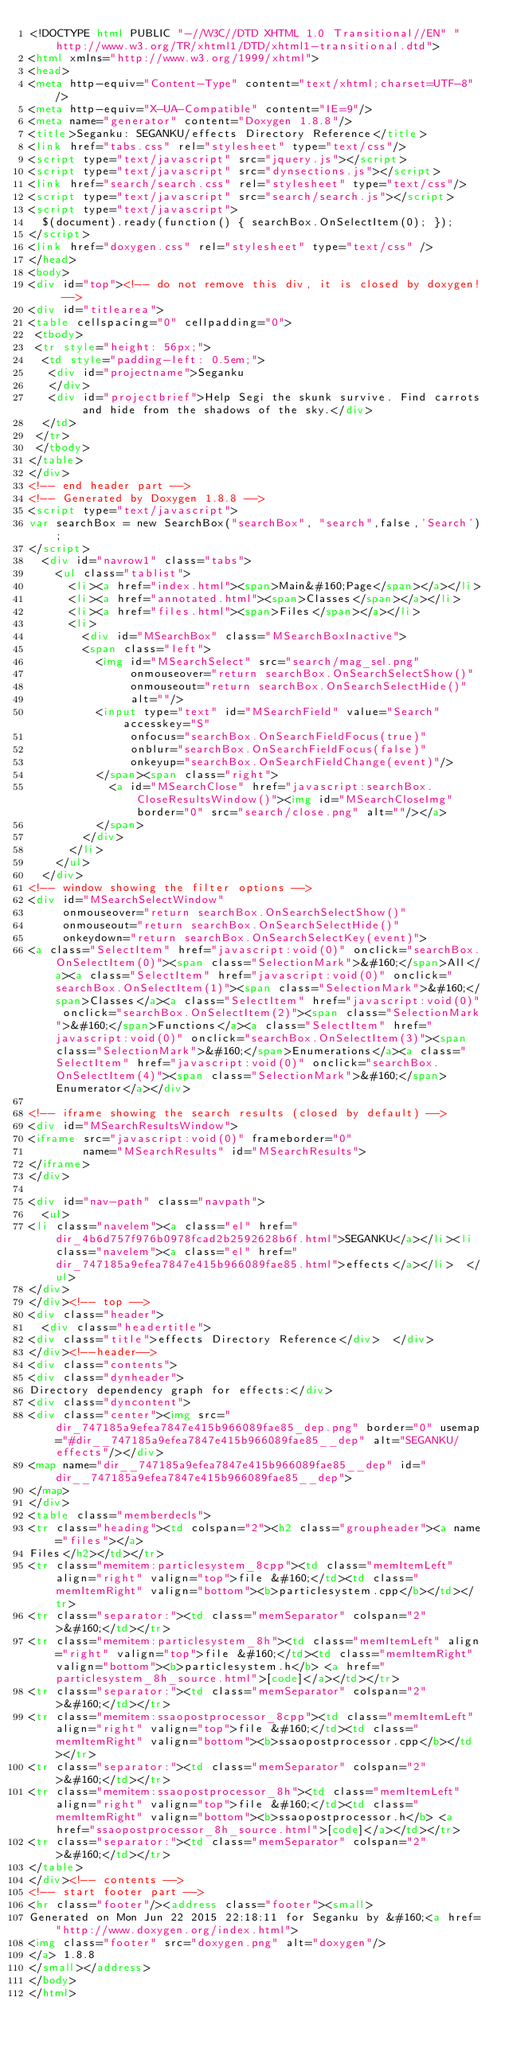<code> <loc_0><loc_0><loc_500><loc_500><_HTML_><!DOCTYPE html PUBLIC "-//W3C//DTD XHTML 1.0 Transitional//EN" "http://www.w3.org/TR/xhtml1/DTD/xhtml1-transitional.dtd">
<html xmlns="http://www.w3.org/1999/xhtml">
<head>
<meta http-equiv="Content-Type" content="text/xhtml;charset=UTF-8"/>
<meta http-equiv="X-UA-Compatible" content="IE=9"/>
<meta name="generator" content="Doxygen 1.8.8"/>
<title>Seganku: SEGANKU/effects Directory Reference</title>
<link href="tabs.css" rel="stylesheet" type="text/css"/>
<script type="text/javascript" src="jquery.js"></script>
<script type="text/javascript" src="dynsections.js"></script>
<link href="search/search.css" rel="stylesheet" type="text/css"/>
<script type="text/javascript" src="search/search.js"></script>
<script type="text/javascript">
  $(document).ready(function() { searchBox.OnSelectItem(0); });
</script>
<link href="doxygen.css" rel="stylesheet" type="text/css" />
</head>
<body>
<div id="top"><!-- do not remove this div, it is closed by doxygen! -->
<div id="titlearea">
<table cellspacing="0" cellpadding="0">
 <tbody>
 <tr style="height: 56px;">
  <td style="padding-left: 0.5em;">
   <div id="projectname">Seganku
   </div>
   <div id="projectbrief">Help Segi the skunk survive. Find carrots and hide from the shadows of the sky.</div>
  </td>
 </tr>
 </tbody>
</table>
</div>
<!-- end header part -->
<!-- Generated by Doxygen 1.8.8 -->
<script type="text/javascript">
var searchBox = new SearchBox("searchBox", "search",false,'Search');
</script>
  <div id="navrow1" class="tabs">
    <ul class="tablist">
      <li><a href="index.html"><span>Main&#160;Page</span></a></li>
      <li><a href="annotated.html"><span>Classes</span></a></li>
      <li><a href="files.html"><span>Files</span></a></li>
      <li>
        <div id="MSearchBox" class="MSearchBoxInactive">
        <span class="left">
          <img id="MSearchSelect" src="search/mag_sel.png"
               onmouseover="return searchBox.OnSearchSelectShow()"
               onmouseout="return searchBox.OnSearchSelectHide()"
               alt=""/>
          <input type="text" id="MSearchField" value="Search" accesskey="S"
               onfocus="searchBox.OnSearchFieldFocus(true)" 
               onblur="searchBox.OnSearchFieldFocus(false)" 
               onkeyup="searchBox.OnSearchFieldChange(event)"/>
          </span><span class="right">
            <a id="MSearchClose" href="javascript:searchBox.CloseResultsWindow()"><img id="MSearchCloseImg" border="0" src="search/close.png" alt=""/></a>
          </span>
        </div>
      </li>
    </ul>
  </div>
<!-- window showing the filter options -->
<div id="MSearchSelectWindow"
     onmouseover="return searchBox.OnSearchSelectShow()"
     onmouseout="return searchBox.OnSearchSelectHide()"
     onkeydown="return searchBox.OnSearchSelectKey(event)">
<a class="SelectItem" href="javascript:void(0)" onclick="searchBox.OnSelectItem(0)"><span class="SelectionMark">&#160;</span>All</a><a class="SelectItem" href="javascript:void(0)" onclick="searchBox.OnSelectItem(1)"><span class="SelectionMark">&#160;</span>Classes</a><a class="SelectItem" href="javascript:void(0)" onclick="searchBox.OnSelectItem(2)"><span class="SelectionMark">&#160;</span>Functions</a><a class="SelectItem" href="javascript:void(0)" onclick="searchBox.OnSelectItem(3)"><span class="SelectionMark">&#160;</span>Enumerations</a><a class="SelectItem" href="javascript:void(0)" onclick="searchBox.OnSelectItem(4)"><span class="SelectionMark">&#160;</span>Enumerator</a></div>

<!-- iframe showing the search results (closed by default) -->
<div id="MSearchResultsWindow">
<iframe src="javascript:void(0)" frameborder="0" 
        name="MSearchResults" id="MSearchResults">
</iframe>
</div>

<div id="nav-path" class="navpath">
  <ul>
<li class="navelem"><a class="el" href="dir_4b6d757f976b0978fcad2b2592628b6f.html">SEGANKU</a></li><li class="navelem"><a class="el" href="dir_747185a9efea7847e415b966089fae85.html">effects</a></li>  </ul>
</div>
</div><!-- top -->
<div class="header">
  <div class="headertitle">
<div class="title">effects Directory Reference</div>  </div>
</div><!--header-->
<div class="contents">
<div class="dynheader">
Directory dependency graph for effects:</div>
<div class="dyncontent">
<div class="center"><img src="dir_747185a9efea7847e415b966089fae85_dep.png" border="0" usemap="#dir__747185a9efea7847e415b966089fae85__dep" alt="SEGANKU/effects"/></div>
<map name="dir__747185a9efea7847e415b966089fae85__dep" id="dir__747185a9efea7847e415b966089fae85__dep">
</map>
</div>
<table class="memberdecls">
<tr class="heading"><td colspan="2"><h2 class="groupheader"><a name="files"></a>
Files</h2></td></tr>
<tr class="memitem:particlesystem_8cpp"><td class="memItemLeft" align="right" valign="top">file &#160;</td><td class="memItemRight" valign="bottom"><b>particlesystem.cpp</b></td></tr>
<tr class="separator:"><td class="memSeparator" colspan="2">&#160;</td></tr>
<tr class="memitem:particlesystem_8h"><td class="memItemLeft" align="right" valign="top">file &#160;</td><td class="memItemRight" valign="bottom"><b>particlesystem.h</b> <a href="particlesystem_8h_source.html">[code]</a></td></tr>
<tr class="separator:"><td class="memSeparator" colspan="2">&#160;</td></tr>
<tr class="memitem:ssaopostprocessor_8cpp"><td class="memItemLeft" align="right" valign="top">file &#160;</td><td class="memItemRight" valign="bottom"><b>ssaopostprocessor.cpp</b></td></tr>
<tr class="separator:"><td class="memSeparator" colspan="2">&#160;</td></tr>
<tr class="memitem:ssaopostprocessor_8h"><td class="memItemLeft" align="right" valign="top">file &#160;</td><td class="memItemRight" valign="bottom"><b>ssaopostprocessor.h</b> <a href="ssaopostprocessor_8h_source.html">[code]</a></td></tr>
<tr class="separator:"><td class="memSeparator" colspan="2">&#160;</td></tr>
</table>
</div><!-- contents -->
<!-- start footer part -->
<hr class="footer"/><address class="footer"><small>
Generated on Mon Jun 22 2015 22:18:11 for Seganku by &#160;<a href="http://www.doxygen.org/index.html">
<img class="footer" src="doxygen.png" alt="doxygen"/>
</a> 1.8.8
</small></address>
</body>
</html>
</code> 